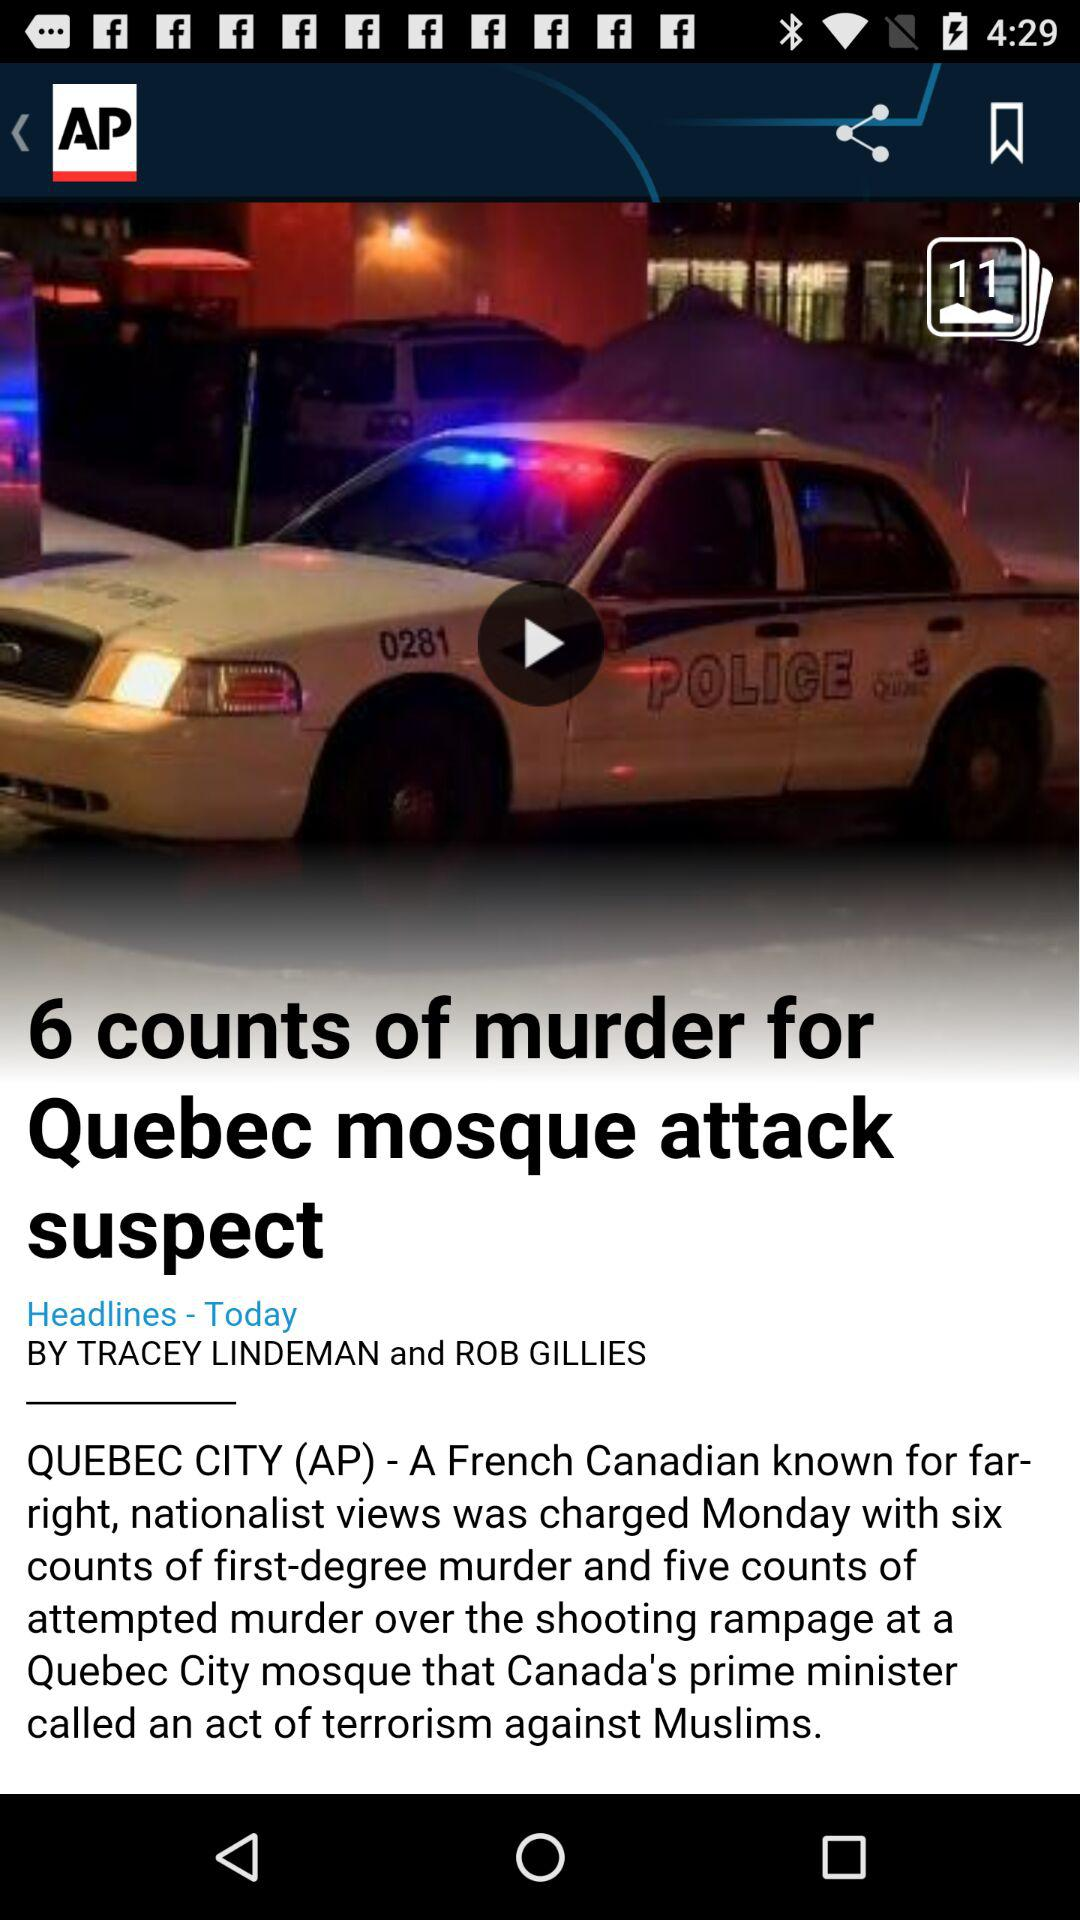What is the name of the news journalist? The names of the news journalists are Tracey Lindeman and Rob Gillies. 